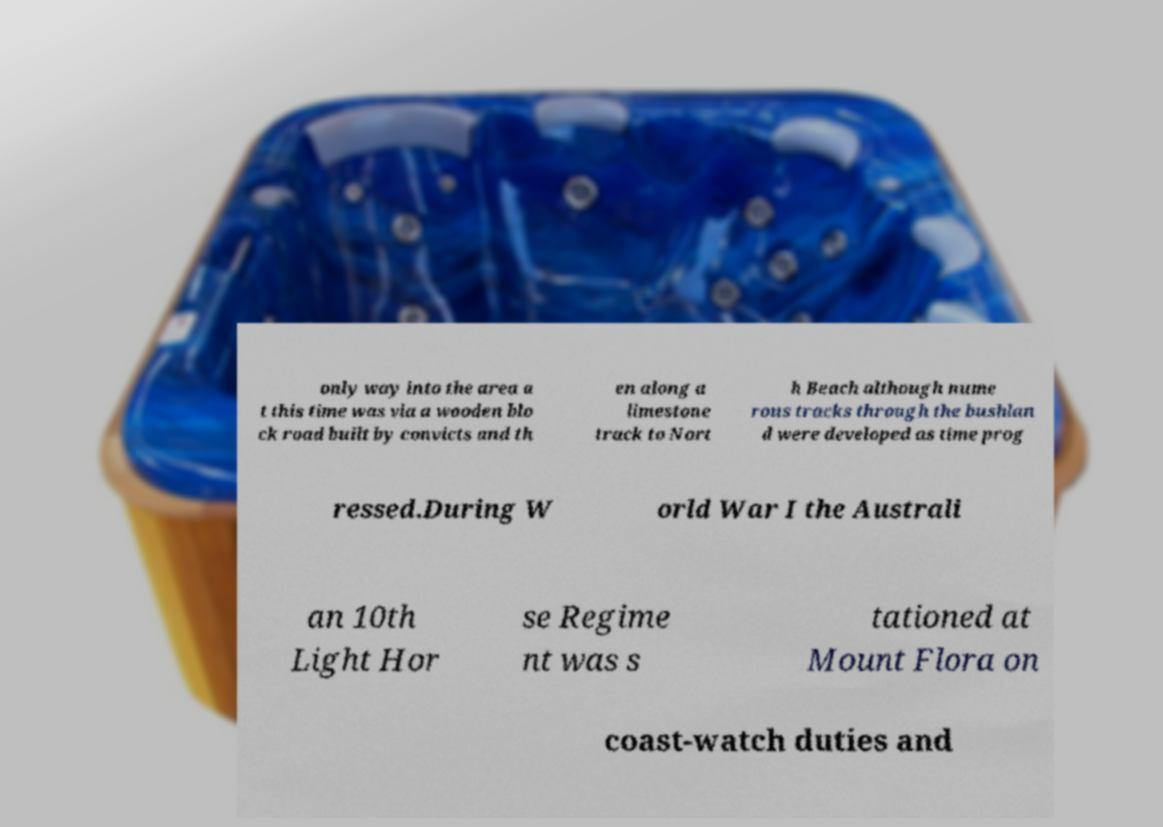Could you extract and type out the text from this image? only way into the area a t this time was via a wooden blo ck road built by convicts and th en along a limestone track to Nort h Beach although nume rous tracks through the bushlan d were developed as time prog ressed.During W orld War I the Australi an 10th Light Hor se Regime nt was s tationed at Mount Flora on coast-watch duties and 